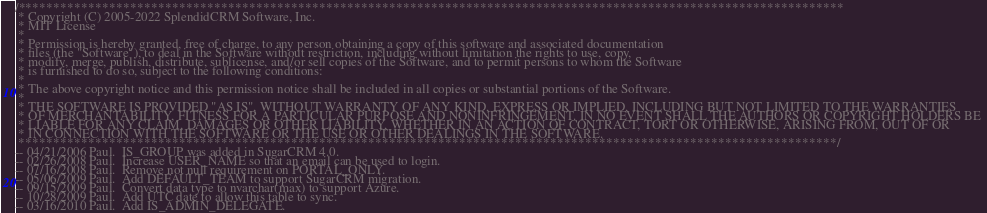<code> <loc_0><loc_0><loc_500><loc_500><_SQL_>/**********************************************************************************************************************
 * Copyright (C) 2005-2022 SplendidCRM Software, Inc. 
 * MIT License
 * 
 * Permission is hereby granted, free of charge, to any person obtaining a copy of this software and associated documentation 
 * files (the "Software"), to deal in the Software without restriction, including without limitation the rights to use, copy, 
 * modify, merge, publish, distribute, sublicense, and/or sell copies of the Software, and to permit persons to whom the Software 
 * is furnished to do so, subject to the following conditions:
 * 
 * The above copyright notice and this permission notice shall be included in all copies or substantial portions of the Software.
 * 
 * THE SOFTWARE IS PROVIDED "AS IS", WITHOUT WARRANTY OF ANY KIND, EXPRESS OR IMPLIED, INCLUDING BUT NOT LIMITED TO THE WARRANTIES 
 * OF MERCHANTABILITY, FITNESS FOR A PARTICULAR PURPOSE AND NONINFRINGEMENT. IN NO EVENT SHALL THE AUTHORS OR COPYRIGHT HOLDERS BE 
 * LIABLE FOR ANY CLAIM, DAMAGES OR OTHER LIABILITY, WHETHER IN AN ACTION OF CONTRACT, TORT OR OTHERWISE, ARISING FROM, OUT OF OR 
 * IN CONNECTION WITH THE SOFTWARE OR THE USE OR OTHER DEALINGS IN THE SOFTWARE.
 *********************************************************************************************************************/
-- 04/21/2006 Paul.  IS_GROUP was added in SugarCRM 4.0.
-- 02/26/2008 Paul.  Increase USER_NAME so that an email can be used to login. 
-- 07/16/2008 Paul.  Remove not null requirement on PORTAL_ONLY. 
-- 05/06/2009 Paul.  Add DEFAULT_TEAM to support SugarCRM migration. 
-- 09/15/2009 Paul.  Convert data type to nvarchar(max) to support Azure. 
-- 10/28/2009 Paul.  Add UTC date to allow this table to sync. 
-- 03/16/2010 Paul.  Add IS_ADMIN_DELEGATE. </code> 